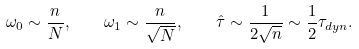<formula> <loc_0><loc_0><loc_500><loc_500>\omega _ { 0 } \sim \frac { n } { N } , \quad \omega _ { 1 } \sim \frac { n } { \sqrt { N } } , \quad \hat { \tau } \sim \frac { 1 } { 2 \sqrt { n } } \sim \frac { 1 } { 2 } \tau _ { d y n } .</formula> 